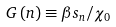<formula> <loc_0><loc_0><loc_500><loc_500>G \left ( n \right ) \equiv \beta s _ { n } / \chi _ { 0 }</formula> 